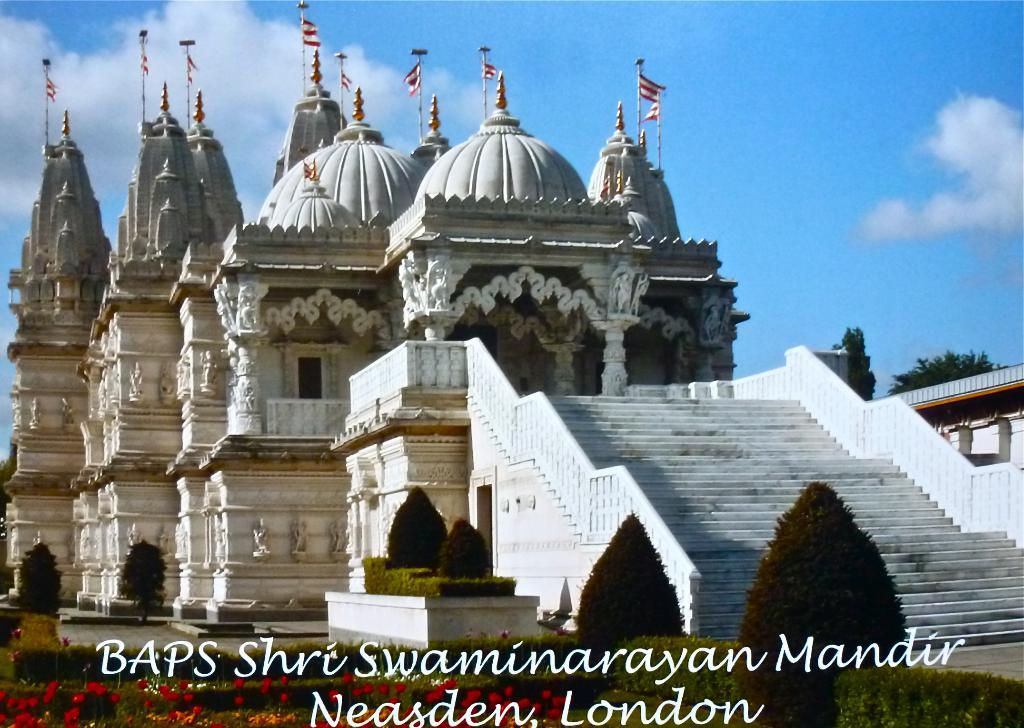What type of vegetation is present in the image? There are plants and trees in green color in the image. What can be seen in the background of the image? There is a building in white color in the background of the image. What colors are the flags in the image? The flags in the image are in white and red color. What colors are visible in the sky in the image? The sky is in blue and white color in the image. How many bikes are parked near the trees in the image? There are no bikes present in the image. Who is the representative of the building in the image? There is no specific representative mentioned or depicted in the image. 